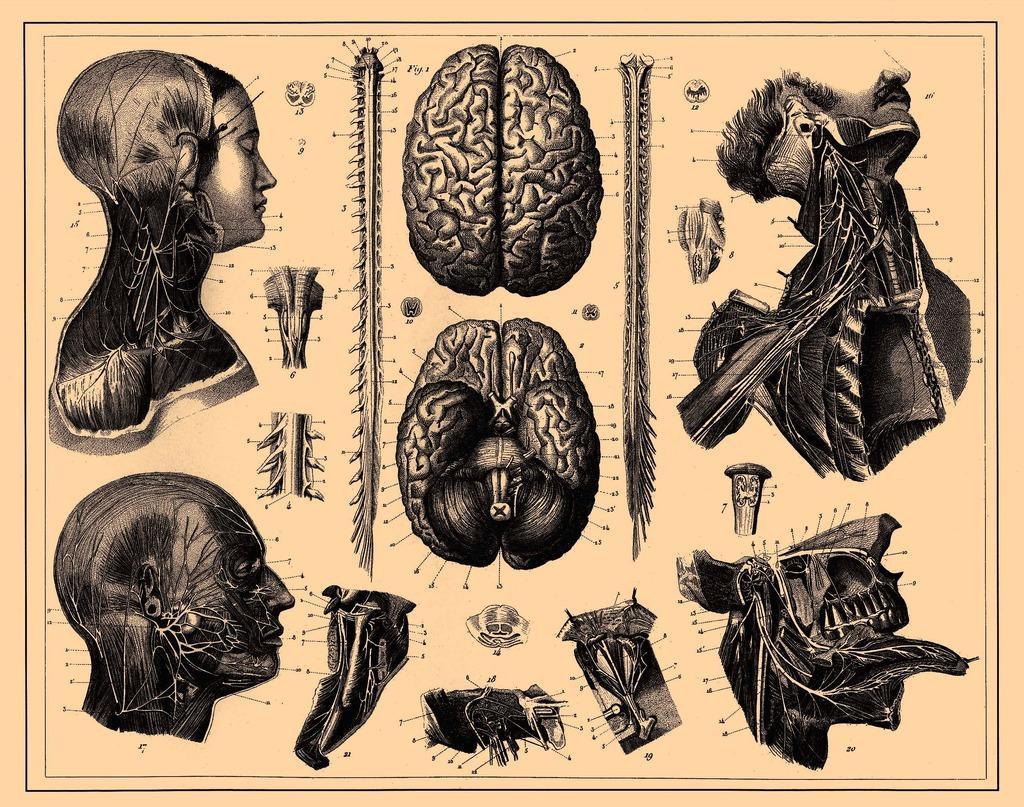In one or two sentences, can you explain what this image depicts? In this picture I can see the depiction pictures of brain, skeletons and other parts of the body. 